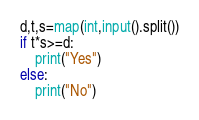Convert code to text. <code><loc_0><loc_0><loc_500><loc_500><_Python_>d,t,s=map(int,input().split())
if t*s>=d:
    print("Yes")
else:
    print("No")</code> 